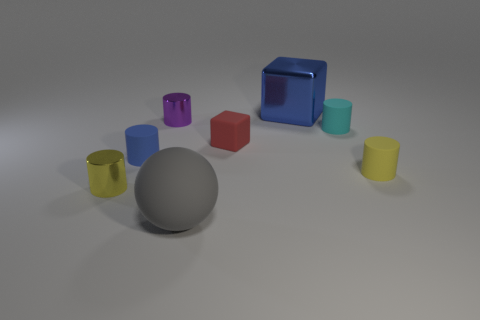Subtract all purple cylinders. How many cylinders are left? 4 Subtract all cyan cylinders. How many cylinders are left? 4 Subtract all brown cylinders. Subtract all blue balls. How many cylinders are left? 5 Add 1 big gray matte balls. How many objects exist? 9 Subtract all cylinders. How many objects are left? 3 Subtract all big brown metal blocks. Subtract all tiny purple metallic cylinders. How many objects are left? 7 Add 3 big blue cubes. How many big blue cubes are left? 4 Add 1 yellow matte balls. How many yellow matte balls exist? 1 Subtract 0 green cylinders. How many objects are left? 8 